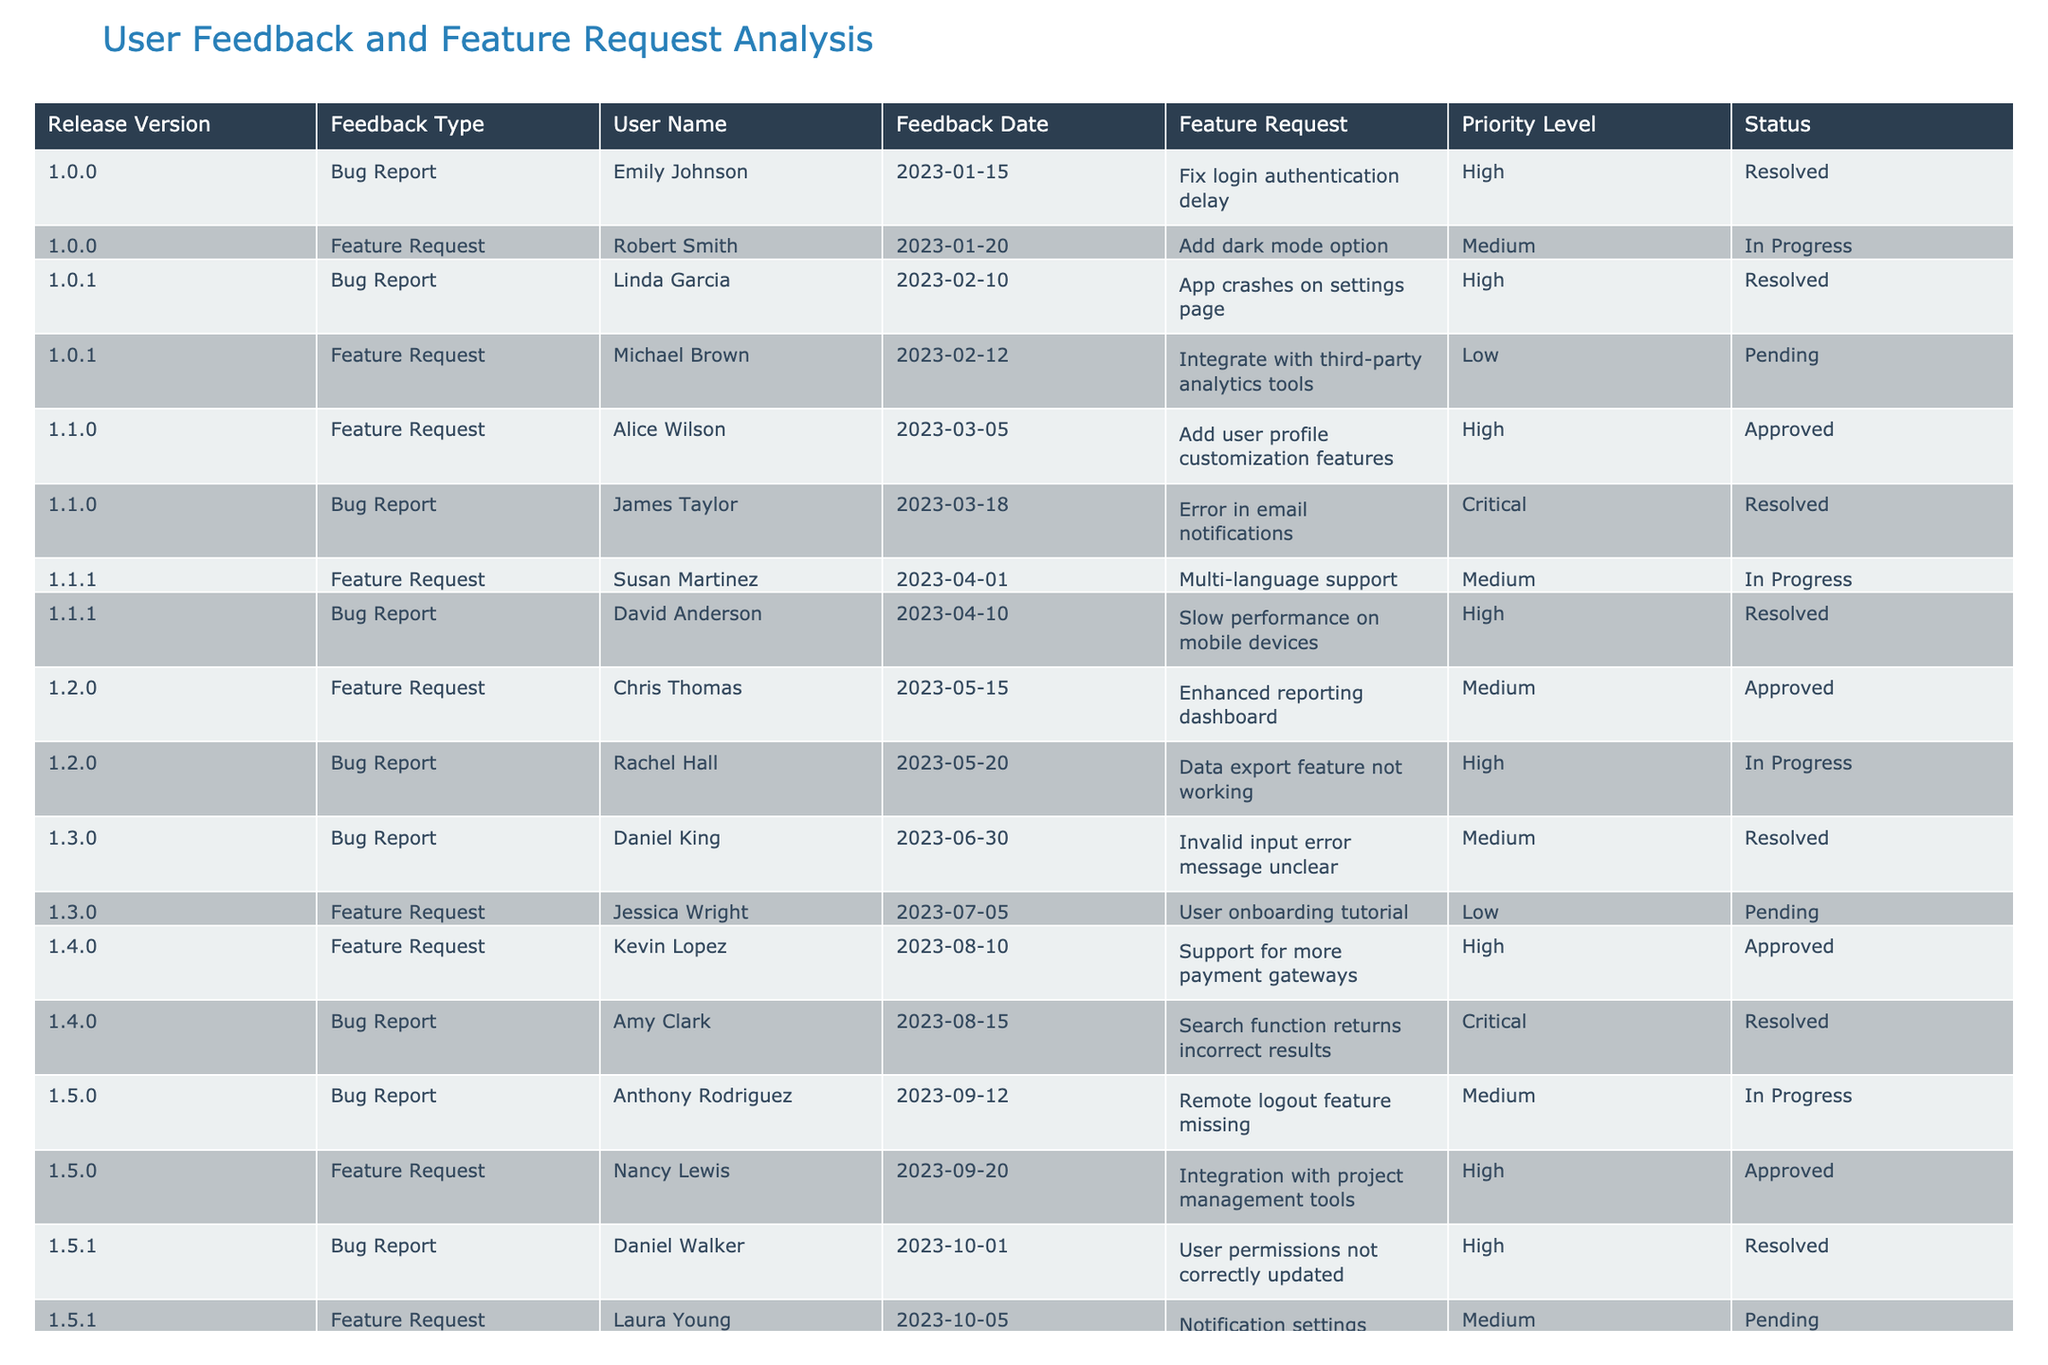What is the highest priority feedback request for release version 1.1.0? In the table, for release version 1.1.0, there are two entries: one for a feature request and one for a bug report. The bug report has a priority level of Critical, while the feature request has a priority level of High. Thus, the highest priority feedback request for this version is the bug report.
Answer: Bug report: "Error in email notifications" How many feature requests were marked as 'Approved' in total? By looking at the status column for feature requests, we see that the following requests are marked as 'Approved': "Add user profile customization features," "Enhanced reporting dashboard," "Support for more payment gateways," and "Integration with project management tools." This gives a total of four approved feature requests.
Answer: 4 Is there a bug report related to the user onboarding tutorial? The table contains a feature request for "User onboarding tutorial," but there is no associated bug report listed directly related to it. Therefore, the fact is False.
Answer: No What is the average priority level of feature requests in the table? To find the average priority level, we first convert the priority levels (High = 3, Medium = 2, Low = 1) for the feature requests: "Add dark mode option" (2), "Integrate with third-party analytics tools" (1), "Add user profile customization features" (3), "Multi-language support" (2), "Enhanced reporting dashboard" (2), "Support for more payment gateways" (3), "Integration with project management tools" (3), "Notification settings enhancement" (2). The sum of these levels is 19, and there are 8 feature requests: 19/8 = 2.375, which corresponds to a Medium priority level.
Answer: Medium Who reported the most recent bug in the table? The most recent bug report is the one dated 2023-10-01, from Daniel Walker, which states: "User permissions not correctly updated." Thus, Daniel Walker reported the most recent bug.
Answer: Daniel Walker Are there any feature requests pending that have a Medium priority level? Looking through the table, we find two pending feature requests: "Integrate with third-party analytics tools" with Low priority and "Notification settings enhancement" with Medium priority. Therefore, the answer is Yes.
Answer: Yes Which release version had the greatest number of bug reports? Examining the table, we see that version 1.1.0 has two entries for bugs, while versions 1.0.1, 1.1.1, 1.4.0, and 1.5.0 each have one bug report, and every other version has one bug report as well. Hence, release version 1.1.0 had the greatest number of bug reports with a total of two.
Answer: 1.1.0 What feedback type has the highest overall priority when considering both feature requests and bug reports? To assess priority, we tally the highest priorities in each category: the maximum priority for bugs is Critical and for features is High. Since Critical is a higher priority than High, the highest overall priority feedback type is a bug report.
Answer: Bug report 